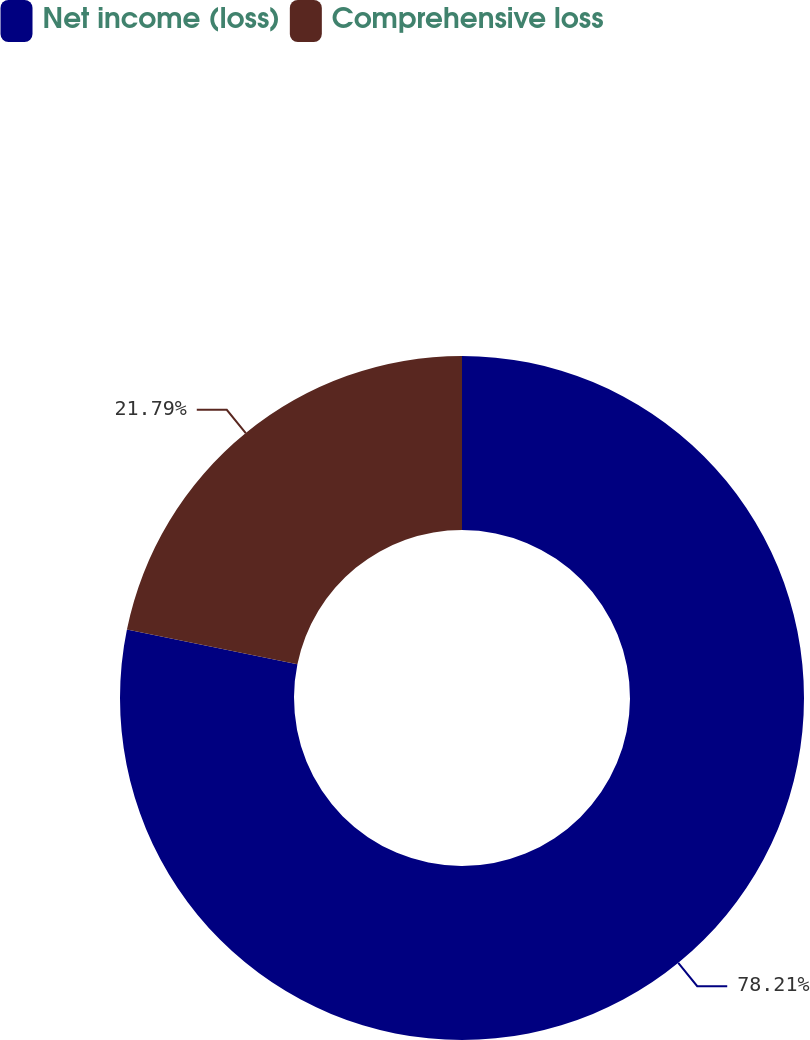Convert chart to OTSL. <chart><loc_0><loc_0><loc_500><loc_500><pie_chart><fcel>Net income (loss)<fcel>Comprehensive loss<nl><fcel>78.21%<fcel>21.79%<nl></chart> 